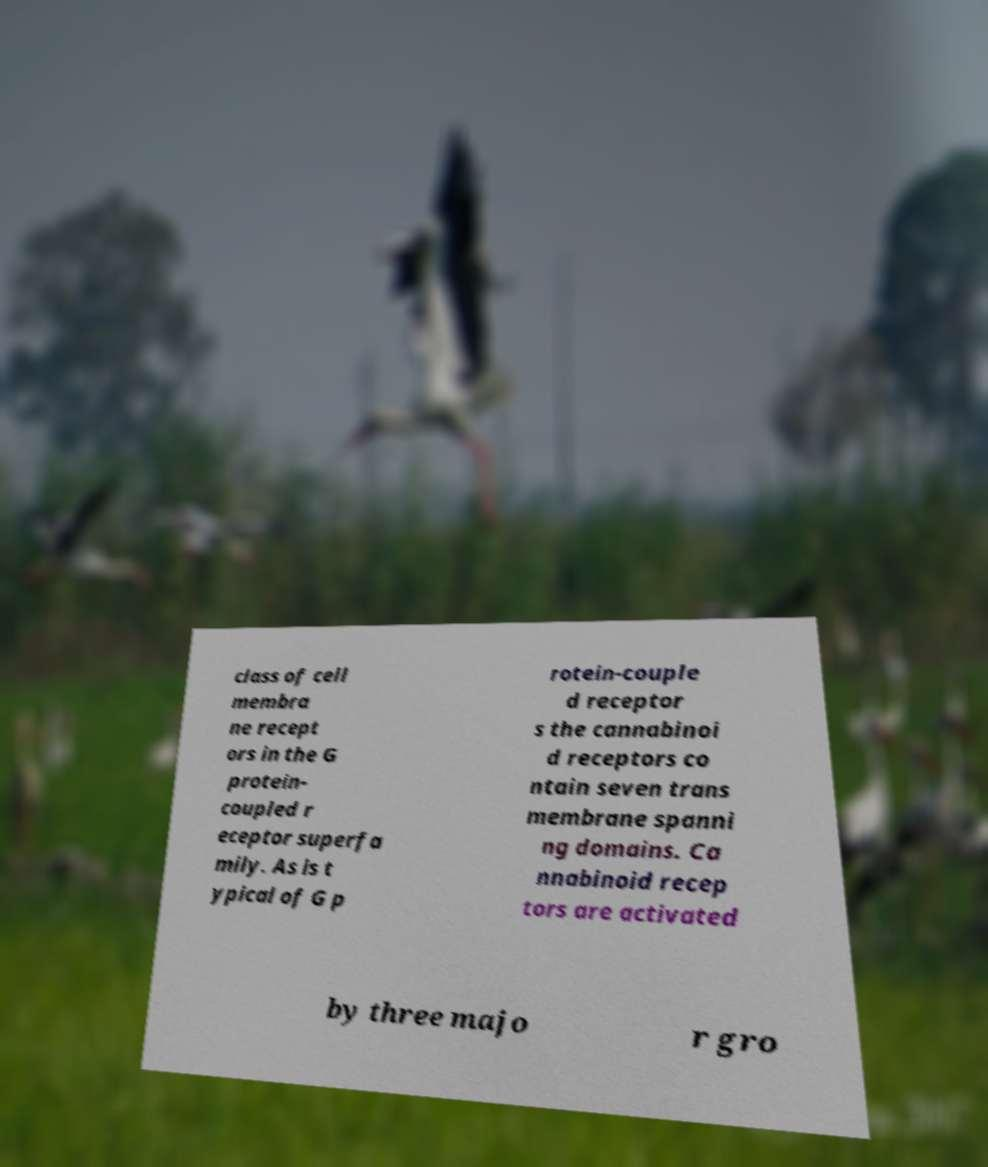For documentation purposes, I need the text within this image transcribed. Could you provide that? class of cell membra ne recept ors in the G protein- coupled r eceptor superfa mily. As is t ypical of G p rotein-couple d receptor s the cannabinoi d receptors co ntain seven trans membrane spanni ng domains. Ca nnabinoid recep tors are activated by three majo r gro 